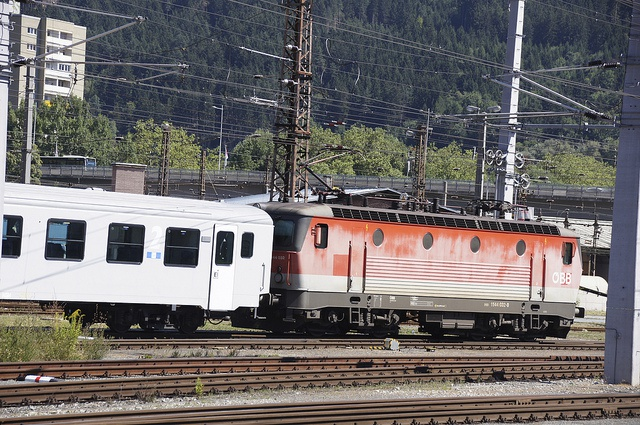Describe the objects in this image and their specific colors. I can see train in black, lightgray, lightpink, and darkgray tones and train in black, white, and gray tones in this image. 